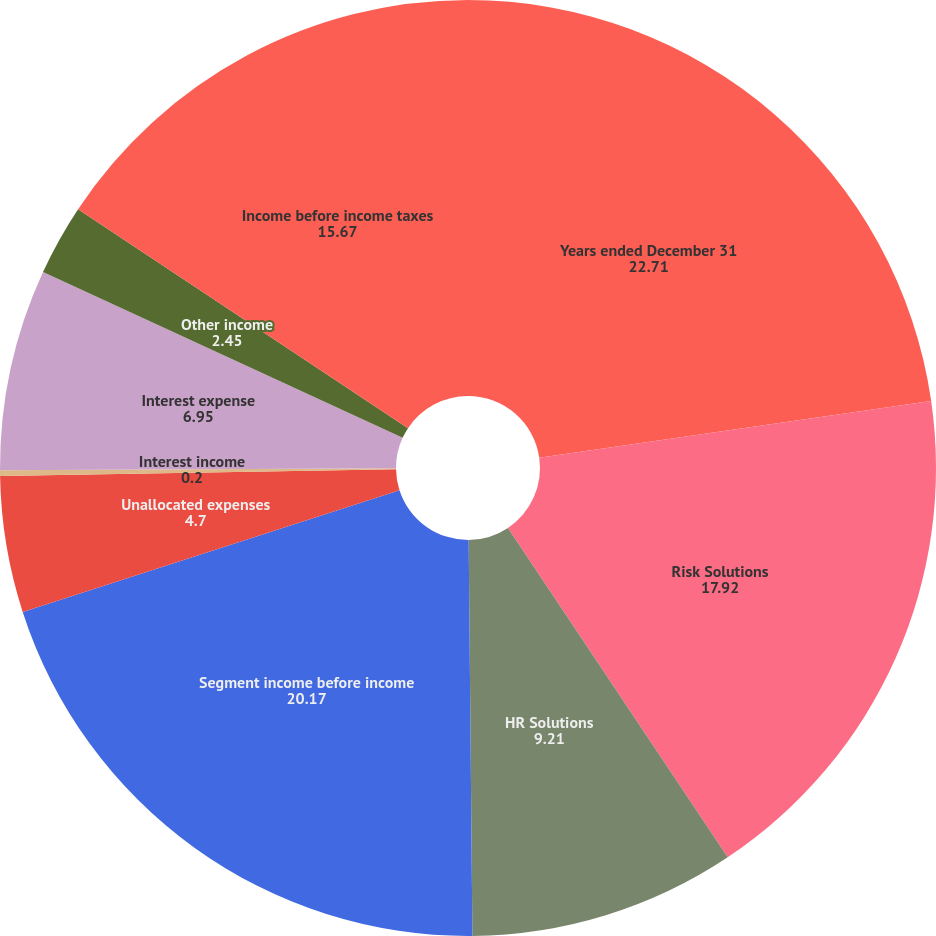<chart> <loc_0><loc_0><loc_500><loc_500><pie_chart><fcel>Years ended December 31<fcel>Risk Solutions<fcel>HR Solutions<fcel>Segment income before income<fcel>Unallocated expenses<fcel>Interest income<fcel>Interest expense<fcel>Other income<fcel>Income before income taxes<nl><fcel>22.71%<fcel>17.92%<fcel>9.21%<fcel>20.17%<fcel>4.7%<fcel>0.2%<fcel>6.95%<fcel>2.45%<fcel>15.67%<nl></chart> 